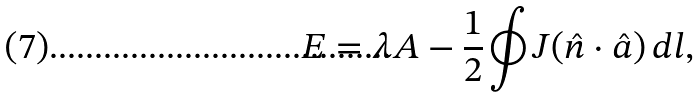Convert formula to latex. <formula><loc_0><loc_0><loc_500><loc_500>E = \lambda A - \frac { 1 } { 2 } \oint J ( \hat { n } \cdot \hat { a } ) \, d l ,</formula> 